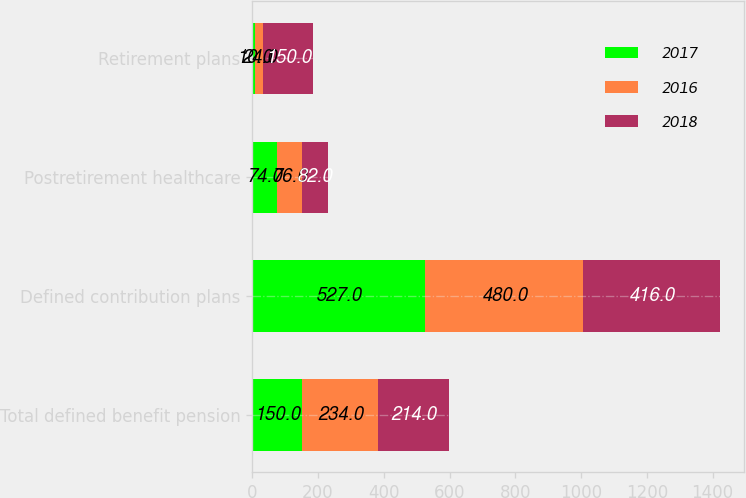<chart> <loc_0><loc_0><loc_500><loc_500><stacked_bar_chart><ecel><fcel>Total defined benefit pension<fcel>Defined contribution plans<fcel>Postretirement healthcare<fcel>Retirement plans<nl><fcel>2017<fcel>150<fcel>527<fcel>74<fcel>10<nl><fcel>2016<fcel>234<fcel>480<fcel>76<fcel>24<nl><fcel>2018<fcel>214<fcel>416<fcel>82<fcel>150<nl></chart> 